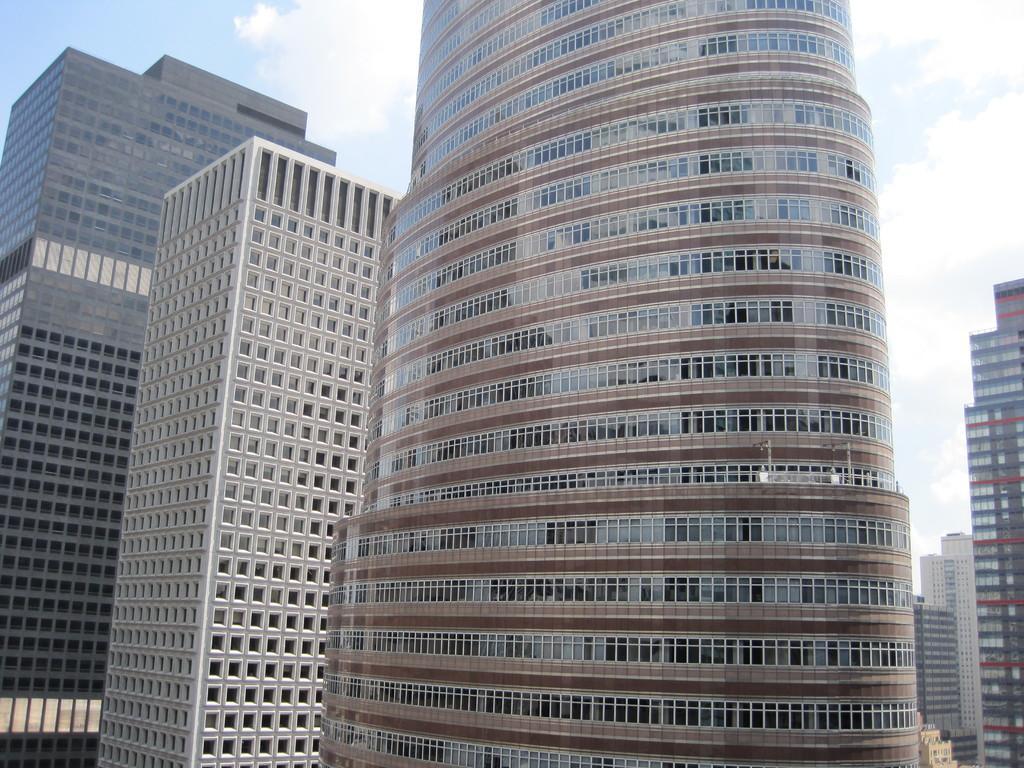Could you give a brief overview of what you see in this image? There are very big buildings with glass walls. At the top it is the blue color sky. 